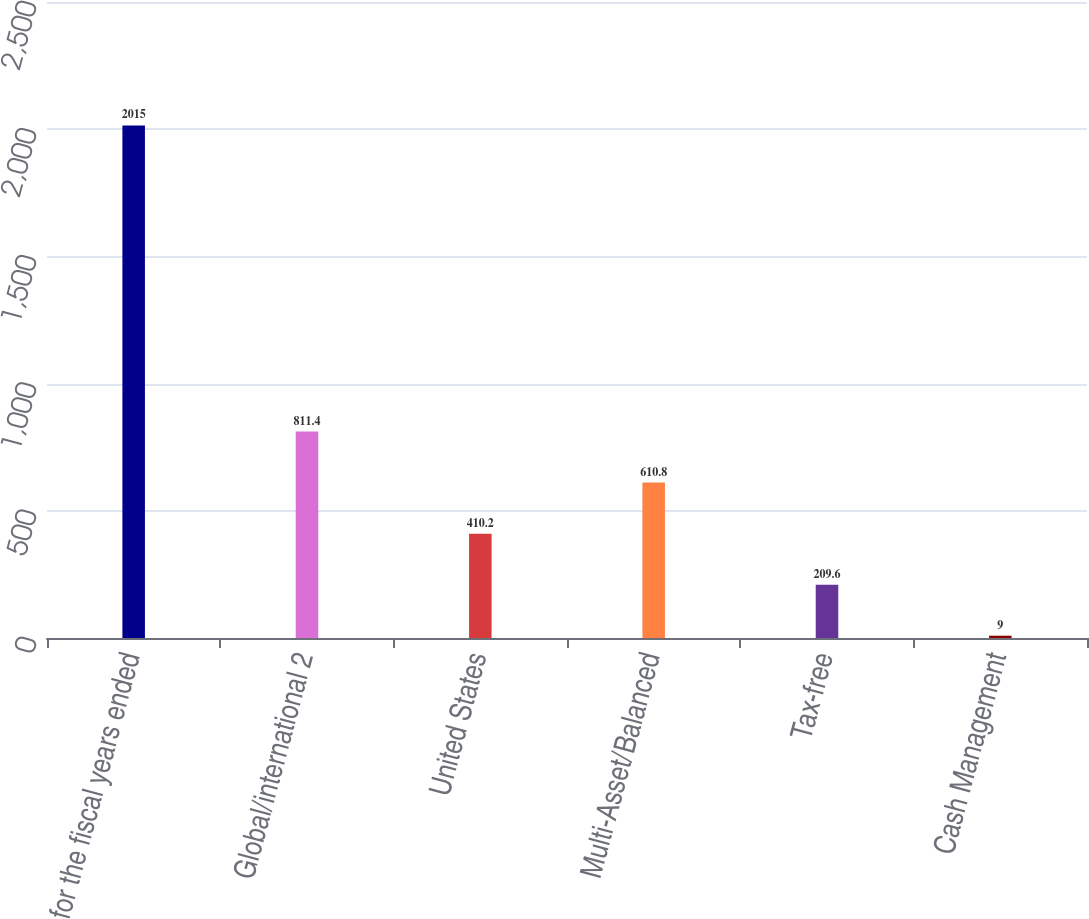<chart> <loc_0><loc_0><loc_500><loc_500><bar_chart><fcel>for the fiscal years ended<fcel>Global/international 2<fcel>United States<fcel>Multi-Asset/Balanced<fcel>Tax-free<fcel>Cash Management<nl><fcel>2015<fcel>811.4<fcel>410.2<fcel>610.8<fcel>209.6<fcel>9<nl></chart> 